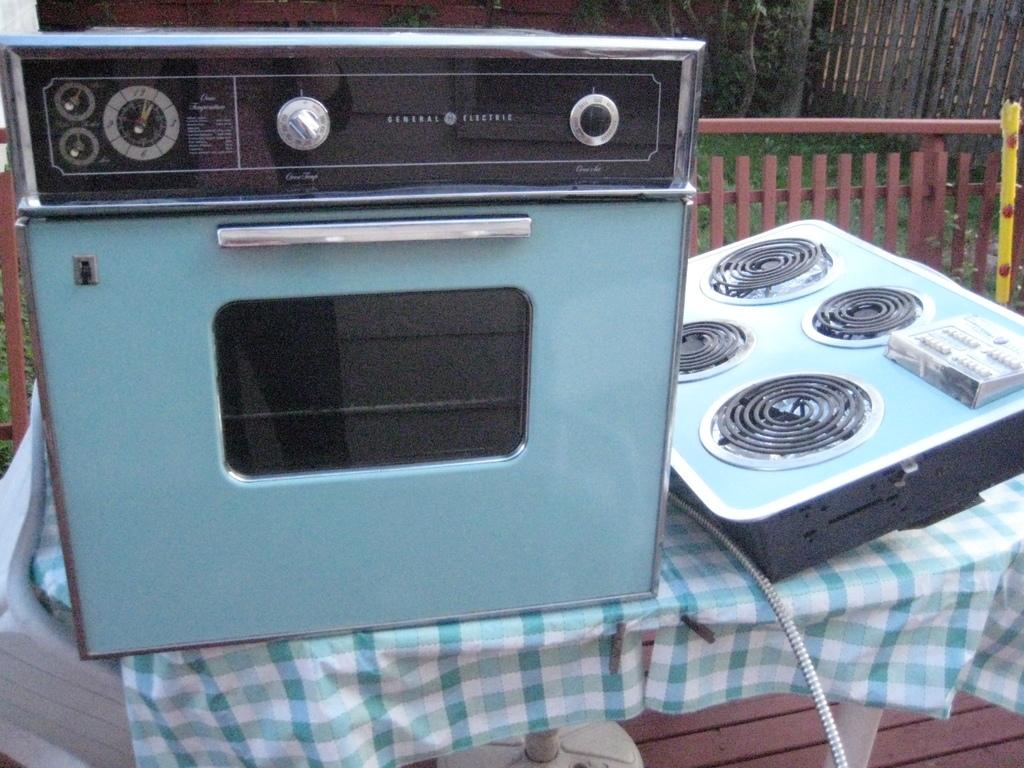What type of stove is visible in the image? There is a gas stove in the image. Where is the cooktop located in the image? The cooktop is on the table in the image. What material is the fence made of in the image? The fence in the image is made of metal. What type of vegetation is present on the surface in the image? There is grass on the surface in the image. How does the sea affect the grass in the image? There is no sea present in the image, so its effect on the grass cannot be determined. What is the condition of the cook's throat in the image? There is no information about the cook's throat in the image. 